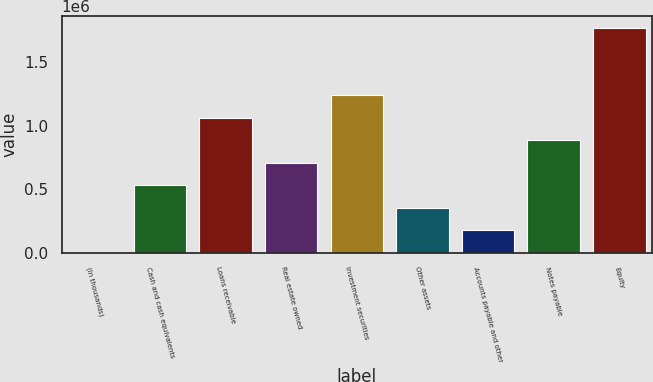Convert chart to OTSL. <chart><loc_0><loc_0><loc_500><loc_500><bar_chart><fcel>(In thousands)<fcel>Cash and cash equivalents<fcel>Loans receivable<fcel>Real estate owned<fcel>Investment securities<fcel>Other assets<fcel>Accounts payable and other<fcel>Notes payable<fcel>Equity<nl><fcel>2014<fcel>531783<fcel>1.06155e+06<fcel>708373<fcel>1.23814e+06<fcel>355194<fcel>178604<fcel>884963<fcel>1.76791e+06<nl></chart> 